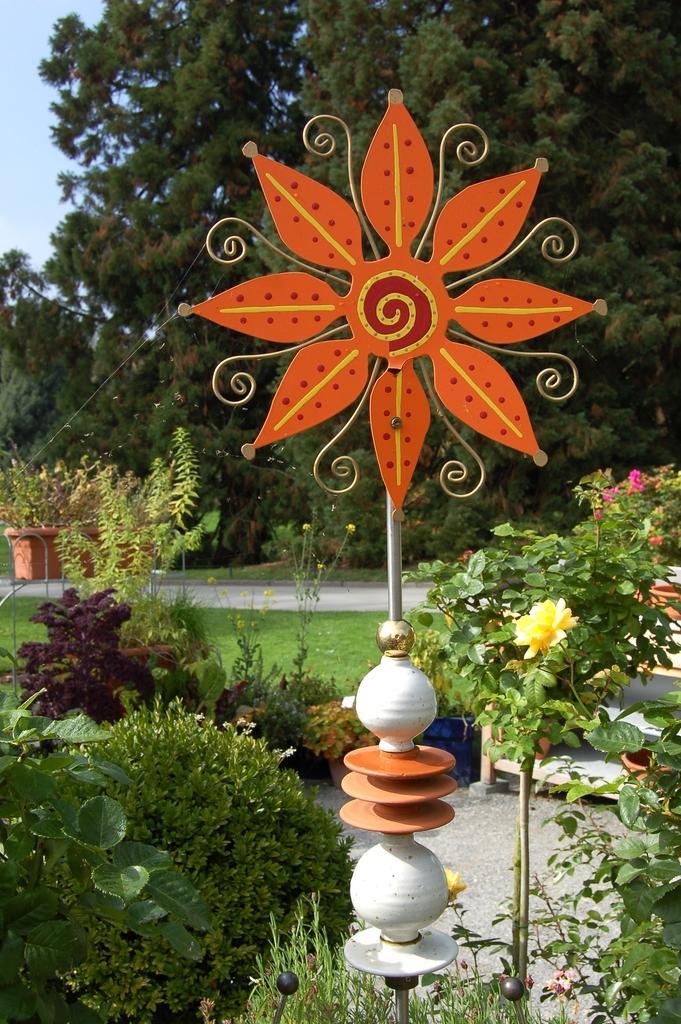Please provide a concise description of this image. In this picture there is an artificial flower made with metal. At the back there are flowers on the plants and there are trees. At the top there is sky. At the bottom there is grass. 